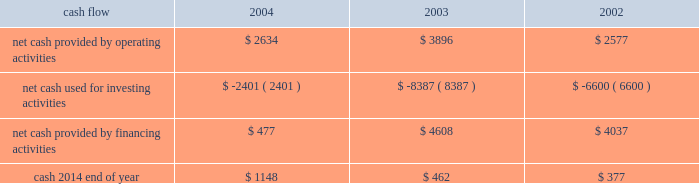On october 21 , 2004 , the hartford declared a dividend on its common stock of $ 0.29 per share payable on january 3 , 2005 to shareholders of record as of december 1 , 2004 .
The hartford declared $ 331 and paid $ 325 in dividends to shareholders in 2004 , declared $ 300 and paid $ 291 in dividends to shareholders in 2003 , declared $ 262 and paid $ 257 in 2002 .
Aoci - aoci increased by $ 179 as of december 31 , 2004 compared with december 31 , 2003 .
The increase in aoci is primarily the result of life 2019s adoption of sop 03-1 , which resulted in a $ 292 cumulative effect for unrealized gains on securities in the first quarter of 2004 related to the reclassification of investments from separate account assets to general account assets , partially offset by net unrealized losses on cash-flow hedging instruments .
The funded status of the company 2019s pension and postretirement plans is dependent upon many factors , including returns on invested assets and the level of market interest rates .
Declines in the value of securities traded in equity markets coupled with declines in long- term interest rates have had a negative impact on the funded status of the plans .
As a result , the company recorded a minimum pension liability as of december 31 , 2004 , and 2003 , which resulted in an after-tax reduction of stockholders 2019 equity of $ 480 and $ 375 respectively .
This minimum pension liability did not affect the company 2019s results of operations .
For additional information on stockholders 2019 equity and aoci see notes 15 and 16 , respectively , of notes to consolidated financial statements .
Cash flow 2004 2003 2002 .
2004 compared to 2003 2014 cash from operating activities primarily reflects premium cash flows in excess of claim payments .
The decrease in cash provided by operating activities was due primarily to the $ 1.15 billion settlement of the macarthur litigation in 2004 .
Cash provided by financing activities decreased primarily due to lower proceeds from investment and universal life-type contracts as a result of the adoption of sop 03-1 , decreased capital raising activities , repayment of commercial paper and early retirement of junior subordinated debentures in 2004 .
The decrease in cash from financing activities and operating cash flows invested long-term accounted for the majority of the change in cash used for investing activities .
2003 compared to 2002 2014 the increase in cash provided by operating activities was primarily the result of strong premium cash flows .
Financing activities increased primarily due to capital raising activities related to the 2003 asbestos reserve addition and decreased due to repayments on long-term debt and lower proceeds from investment and universal life-type contracts .
The increase in cash from financing activities accounted for the majority of the change in cash used for investing activities .
Operating cash flows in each of the last three years have been adequate to meet liquidity requirements .
Equity markets for a discussion of the potential impact of the equity markets on capital and liquidity , see the capital markets risk management section under 201cmarket risk 201d .
Ratings ratings are an important factor in establishing the competitive position in the insurance and financial services marketplace .
There can be no assurance that the company's ratings will continue for any given period of time or that they will not be changed .
In the event the company's ratings are downgraded , the level of revenues or the persistency of the company's business may be adversely impacted .
On august 4 , 2004 , moody 2019s affirmed the company 2019s and hartford life , inc . 2019s a3 senior debt ratings as well as the aa3 insurance financial strength ratings of both its property-casualty and life insurance operating subsidiaries .
In addition , moody 2019s changed the outlook for all of these ratings from negative to stable .
Since the announcement of the suit filed by the new york attorney general 2019s office against marsh & mclennan companies , inc. , and marsh , inc .
On october 14 , 2004 , the major independent ratings agencies have indicated that they continue to monitor developments relating to the suit .
On october 22 , 2004 , standard & poor 2019s revised its outlook on the u.s .
Property/casualty commercial lines sector to negative from stable .
On november 23 , 2004 , standard & poor 2019s revised its outlook on the financial strength and credit ratings of the property-casualty insurance subsidiaries to negative from stable .
The outlook on the life insurance subsidiaries and corporate debt was unaffected. .
In 2004 what was the net change in cash? 
Computations: ((2634 + 2401) + 477)
Answer: 5512.0. 